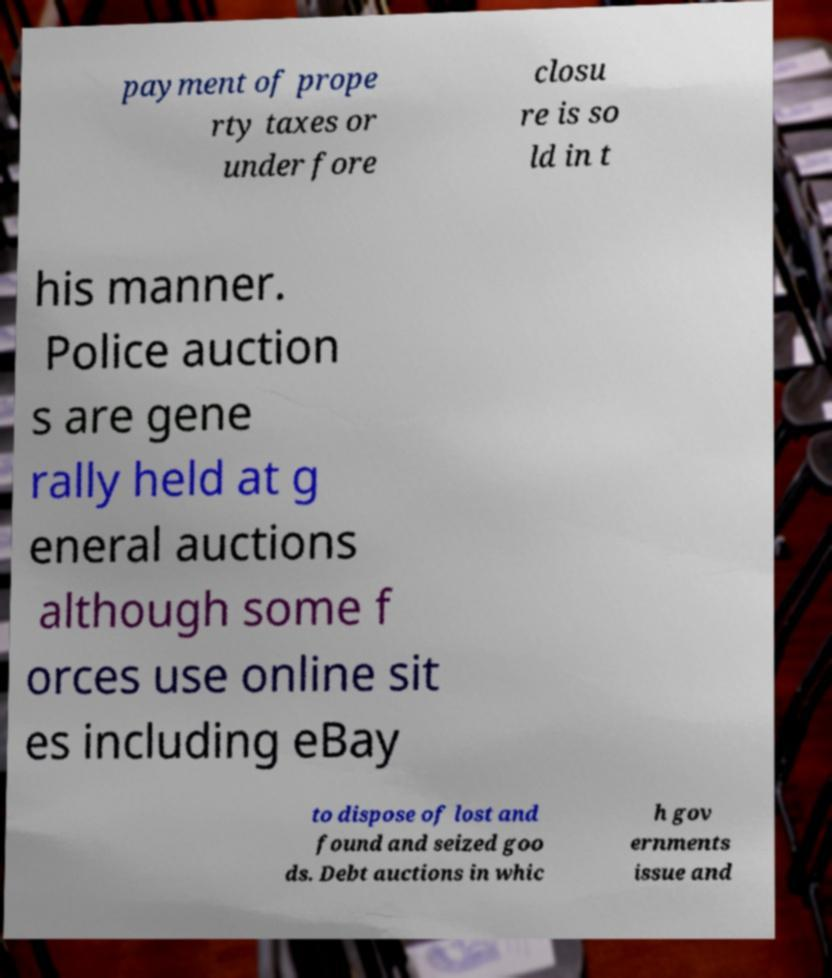There's text embedded in this image that I need extracted. Can you transcribe it verbatim? payment of prope rty taxes or under fore closu re is so ld in t his manner. Police auction s are gene rally held at g eneral auctions although some f orces use online sit es including eBay to dispose of lost and found and seized goo ds. Debt auctions in whic h gov ernments issue and 